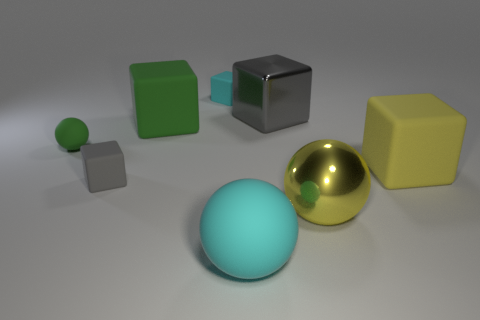There is a small matte object to the right of the large green matte block; what color is it? The small matte object to the right of the large green block is grey in color. Its surface appears smooth and it has a cubical shape, which contrasts with the more rounded forms of the objects in the foreground. 